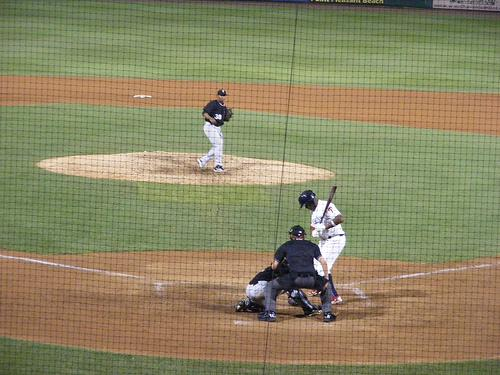Question: who is wearing white gloves?
Choices:
A. The chef.
B. The batter.
C. The doctor.
D. The mechanic.
Answer with the letter. Answer: B Question: what color are the batter's pants?
Choices:
A. Brown.
B. White.
C. Blue.
D. Grey.
Answer with the letter. Answer: B Question: how many people are in this photo?
Choices:
A. Three.
B. Four.
C. Ten.
D. Six.
Answer with the letter. Answer: B 